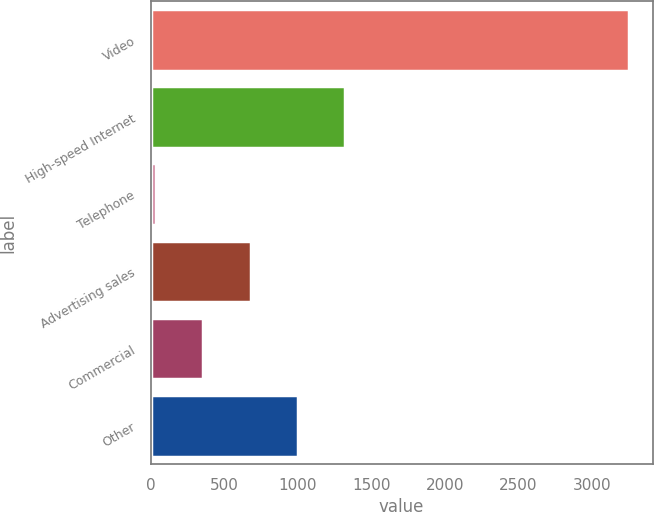<chart> <loc_0><loc_0><loc_500><loc_500><bar_chart><fcel>Video<fcel>High-speed Internet<fcel>Telephone<fcel>Advertising sales<fcel>Commercial<fcel>Other<nl><fcel>3248<fcel>1320.8<fcel>36<fcel>678.4<fcel>357.2<fcel>999.6<nl></chart> 